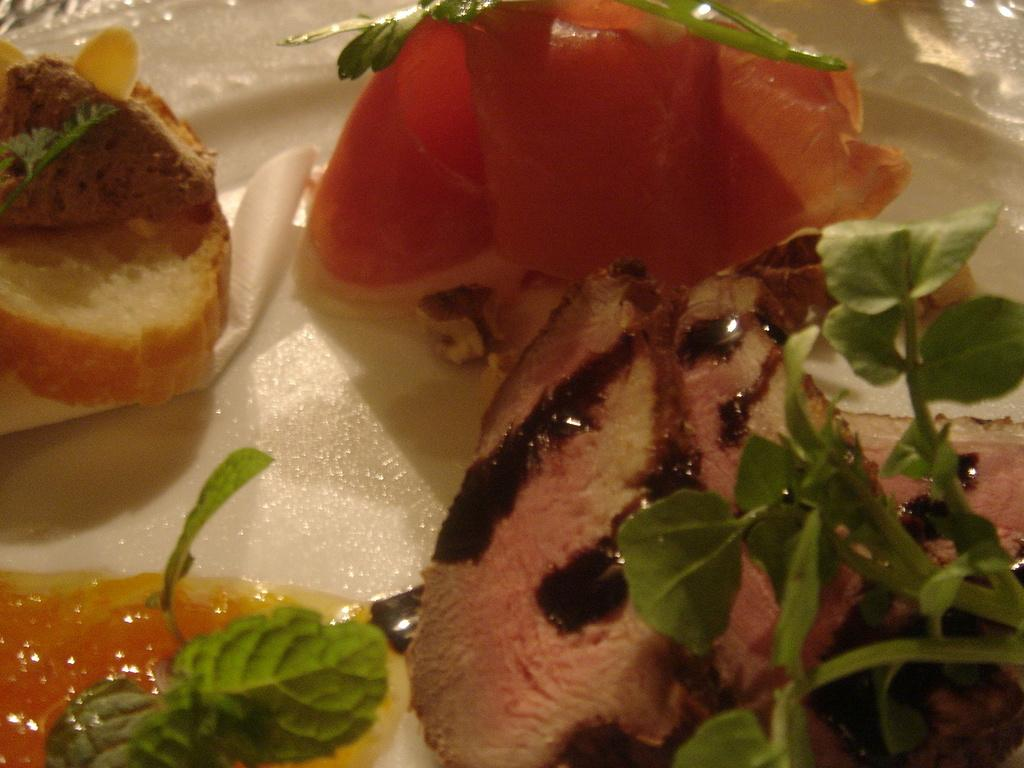What is on the plate in the image? There are food items on a plate in the image. What else can be seen on the plate besides the food items? There are leaves on the plate in the image. What type of bone can be seen in the image? There is no bone present in the image; it only features food items and leaves on a plate. 